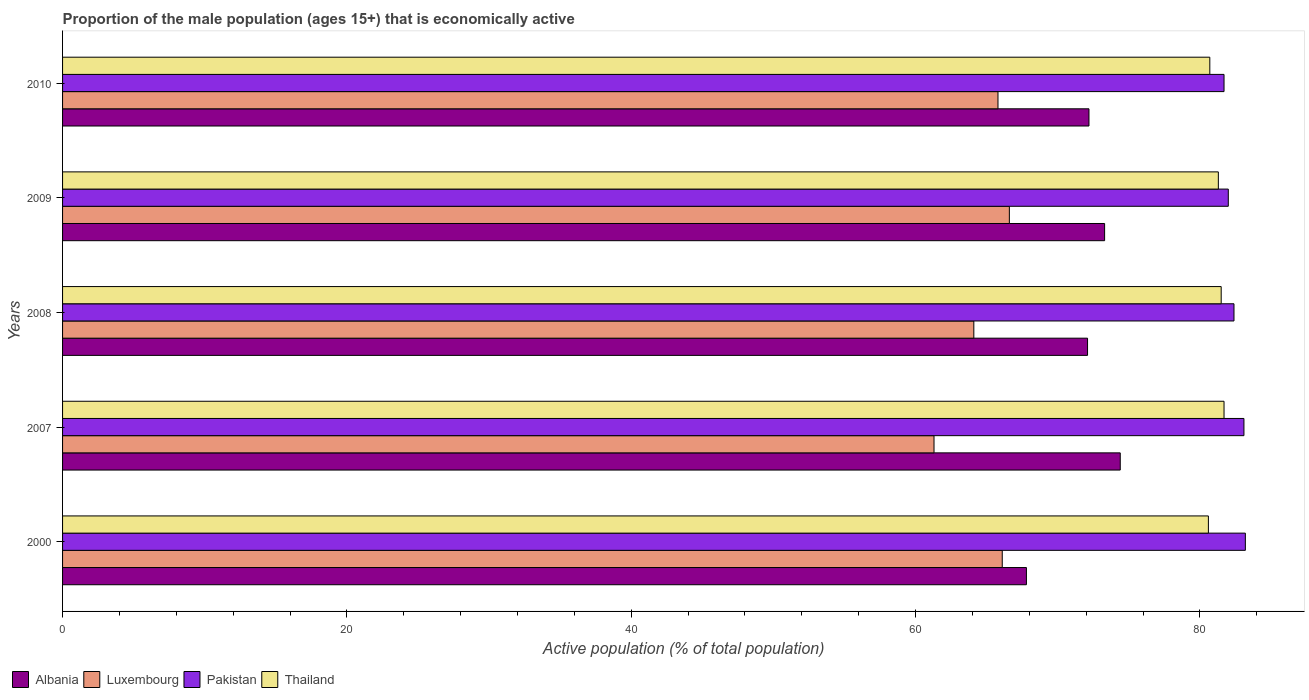Are the number of bars per tick equal to the number of legend labels?
Your answer should be very brief. Yes. Are the number of bars on each tick of the Y-axis equal?
Ensure brevity in your answer.  Yes. How many bars are there on the 2nd tick from the bottom?
Keep it short and to the point. 4. What is the proportion of the male population that is economically active in Thailand in 2009?
Your response must be concise. 81.3. Across all years, what is the maximum proportion of the male population that is economically active in Albania?
Offer a terse response. 74.4. Across all years, what is the minimum proportion of the male population that is economically active in Albania?
Give a very brief answer. 67.8. In which year was the proportion of the male population that is economically active in Thailand maximum?
Your answer should be very brief. 2007. What is the total proportion of the male population that is economically active in Albania in the graph?
Give a very brief answer. 359.8. What is the difference between the proportion of the male population that is economically active in Thailand in 2008 and that in 2009?
Your answer should be compact. 0.2. What is the difference between the proportion of the male population that is economically active in Pakistan in 2000 and the proportion of the male population that is economically active in Albania in 2008?
Provide a succinct answer. 11.1. What is the average proportion of the male population that is economically active in Albania per year?
Provide a short and direct response. 71.96. In the year 2010, what is the difference between the proportion of the male population that is economically active in Albania and proportion of the male population that is economically active in Luxembourg?
Provide a succinct answer. 6.4. What is the ratio of the proportion of the male population that is economically active in Thailand in 2000 to that in 2009?
Ensure brevity in your answer.  0.99. Is the proportion of the male population that is economically active in Thailand in 2000 less than that in 2009?
Give a very brief answer. Yes. Is the difference between the proportion of the male population that is economically active in Albania in 2000 and 2007 greater than the difference between the proportion of the male population that is economically active in Luxembourg in 2000 and 2007?
Keep it short and to the point. No. What is the difference between the highest and the lowest proportion of the male population that is economically active in Thailand?
Give a very brief answer. 1.1. Is the sum of the proportion of the male population that is economically active in Albania in 2007 and 2010 greater than the maximum proportion of the male population that is economically active in Pakistan across all years?
Provide a short and direct response. Yes. What does the 3rd bar from the top in 2010 represents?
Give a very brief answer. Luxembourg. How many bars are there?
Your answer should be very brief. 20. How many years are there in the graph?
Make the answer very short. 5. What is the difference between two consecutive major ticks on the X-axis?
Give a very brief answer. 20. Are the values on the major ticks of X-axis written in scientific E-notation?
Give a very brief answer. No. Does the graph contain grids?
Make the answer very short. No. Where does the legend appear in the graph?
Your answer should be compact. Bottom left. What is the title of the graph?
Provide a succinct answer. Proportion of the male population (ages 15+) that is economically active. Does "China" appear as one of the legend labels in the graph?
Ensure brevity in your answer.  No. What is the label or title of the X-axis?
Make the answer very short. Active population (% of total population). What is the label or title of the Y-axis?
Keep it short and to the point. Years. What is the Active population (% of total population) in Albania in 2000?
Ensure brevity in your answer.  67.8. What is the Active population (% of total population) of Luxembourg in 2000?
Your answer should be compact. 66.1. What is the Active population (% of total population) in Pakistan in 2000?
Your answer should be very brief. 83.2. What is the Active population (% of total population) of Thailand in 2000?
Ensure brevity in your answer.  80.6. What is the Active population (% of total population) of Albania in 2007?
Your answer should be very brief. 74.4. What is the Active population (% of total population) in Luxembourg in 2007?
Offer a terse response. 61.3. What is the Active population (% of total population) in Pakistan in 2007?
Ensure brevity in your answer.  83.1. What is the Active population (% of total population) of Thailand in 2007?
Provide a short and direct response. 81.7. What is the Active population (% of total population) of Albania in 2008?
Keep it short and to the point. 72.1. What is the Active population (% of total population) of Luxembourg in 2008?
Ensure brevity in your answer.  64.1. What is the Active population (% of total population) in Pakistan in 2008?
Offer a terse response. 82.4. What is the Active population (% of total population) of Thailand in 2008?
Make the answer very short. 81.5. What is the Active population (% of total population) in Albania in 2009?
Provide a short and direct response. 73.3. What is the Active population (% of total population) of Luxembourg in 2009?
Make the answer very short. 66.6. What is the Active population (% of total population) in Pakistan in 2009?
Your response must be concise. 82. What is the Active population (% of total population) in Thailand in 2009?
Provide a succinct answer. 81.3. What is the Active population (% of total population) in Albania in 2010?
Give a very brief answer. 72.2. What is the Active population (% of total population) of Luxembourg in 2010?
Give a very brief answer. 65.8. What is the Active population (% of total population) of Pakistan in 2010?
Offer a terse response. 81.7. What is the Active population (% of total population) of Thailand in 2010?
Your response must be concise. 80.7. Across all years, what is the maximum Active population (% of total population) of Albania?
Ensure brevity in your answer.  74.4. Across all years, what is the maximum Active population (% of total population) of Luxembourg?
Provide a short and direct response. 66.6. Across all years, what is the maximum Active population (% of total population) in Pakistan?
Make the answer very short. 83.2. Across all years, what is the maximum Active population (% of total population) in Thailand?
Keep it short and to the point. 81.7. Across all years, what is the minimum Active population (% of total population) in Albania?
Provide a succinct answer. 67.8. Across all years, what is the minimum Active population (% of total population) in Luxembourg?
Offer a terse response. 61.3. Across all years, what is the minimum Active population (% of total population) in Pakistan?
Provide a short and direct response. 81.7. Across all years, what is the minimum Active population (% of total population) in Thailand?
Your answer should be very brief. 80.6. What is the total Active population (% of total population) of Albania in the graph?
Provide a succinct answer. 359.8. What is the total Active population (% of total population) in Luxembourg in the graph?
Offer a very short reply. 323.9. What is the total Active population (% of total population) of Pakistan in the graph?
Your answer should be very brief. 412.4. What is the total Active population (% of total population) of Thailand in the graph?
Keep it short and to the point. 405.8. What is the difference between the Active population (% of total population) in Albania in 2000 and that in 2007?
Offer a very short reply. -6.6. What is the difference between the Active population (% of total population) of Pakistan in 2000 and that in 2007?
Provide a short and direct response. 0.1. What is the difference between the Active population (% of total population) of Thailand in 2000 and that in 2007?
Provide a short and direct response. -1.1. What is the difference between the Active population (% of total population) of Albania in 2000 and that in 2008?
Provide a succinct answer. -4.3. What is the difference between the Active population (% of total population) in Pakistan in 2000 and that in 2008?
Offer a very short reply. 0.8. What is the difference between the Active population (% of total population) in Pakistan in 2000 and that in 2009?
Your response must be concise. 1.2. What is the difference between the Active population (% of total population) in Thailand in 2000 and that in 2009?
Provide a short and direct response. -0.7. What is the difference between the Active population (% of total population) of Albania in 2000 and that in 2010?
Offer a terse response. -4.4. What is the difference between the Active population (% of total population) of Albania in 2007 and that in 2008?
Your answer should be compact. 2.3. What is the difference between the Active population (% of total population) of Luxembourg in 2007 and that in 2008?
Your answer should be very brief. -2.8. What is the difference between the Active population (% of total population) of Pakistan in 2007 and that in 2008?
Make the answer very short. 0.7. What is the difference between the Active population (% of total population) in Albania in 2007 and that in 2009?
Offer a terse response. 1.1. What is the difference between the Active population (% of total population) in Luxembourg in 2007 and that in 2009?
Keep it short and to the point. -5.3. What is the difference between the Active population (% of total population) of Pakistan in 2007 and that in 2009?
Give a very brief answer. 1.1. What is the difference between the Active population (% of total population) of Luxembourg in 2007 and that in 2010?
Offer a terse response. -4.5. What is the difference between the Active population (% of total population) in Pakistan in 2007 and that in 2010?
Make the answer very short. 1.4. What is the difference between the Active population (% of total population) of Thailand in 2007 and that in 2010?
Make the answer very short. 1. What is the difference between the Active population (% of total population) of Pakistan in 2008 and that in 2009?
Keep it short and to the point. 0.4. What is the difference between the Active population (% of total population) of Thailand in 2008 and that in 2009?
Keep it short and to the point. 0.2. What is the difference between the Active population (% of total population) of Albania in 2008 and that in 2010?
Your response must be concise. -0.1. What is the difference between the Active population (% of total population) of Pakistan in 2008 and that in 2010?
Offer a very short reply. 0.7. What is the difference between the Active population (% of total population) in Albania in 2009 and that in 2010?
Offer a very short reply. 1.1. What is the difference between the Active population (% of total population) of Albania in 2000 and the Active population (% of total population) of Luxembourg in 2007?
Provide a succinct answer. 6.5. What is the difference between the Active population (% of total population) in Albania in 2000 and the Active population (% of total population) in Pakistan in 2007?
Offer a very short reply. -15.3. What is the difference between the Active population (% of total population) of Luxembourg in 2000 and the Active population (% of total population) of Pakistan in 2007?
Your answer should be very brief. -17. What is the difference between the Active population (% of total population) in Luxembourg in 2000 and the Active population (% of total population) in Thailand in 2007?
Provide a short and direct response. -15.6. What is the difference between the Active population (% of total population) in Pakistan in 2000 and the Active population (% of total population) in Thailand in 2007?
Your answer should be very brief. 1.5. What is the difference between the Active population (% of total population) of Albania in 2000 and the Active population (% of total population) of Luxembourg in 2008?
Offer a very short reply. 3.7. What is the difference between the Active population (% of total population) in Albania in 2000 and the Active population (% of total population) in Pakistan in 2008?
Keep it short and to the point. -14.6. What is the difference between the Active population (% of total population) of Albania in 2000 and the Active population (% of total population) of Thailand in 2008?
Provide a short and direct response. -13.7. What is the difference between the Active population (% of total population) in Luxembourg in 2000 and the Active population (% of total population) in Pakistan in 2008?
Make the answer very short. -16.3. What is the difference between the Active population (% of total population) in Luxembourg in 2000 and the Active population (% of total population) in Thailand in 2008?
Keep it short and to the point. -15.4. What is the difference between the Active population (% of total population) of Albania in 2000 and the Active population (% of total population) of Luxembourg in 2009?
Provide a succinct answer. 1.2. What is the difference between the Active population (% of total population) in Albania in 2000 and the Active population (% of total population) in Pakistan in 2009?
Your answer should be compact. -14.2. What is the difference between the Active population (% of total population) in Albania in 2000 and the Active population (% of total population) in Thailand in 2009?
Ensure brevity in your answer.  -13.5. What is the difference between the Active population (% of total population) of Luxembourg in 2000 and the Active population (% of total population) of Pakistan in 2009?
Give a very brief answer. -15.9. What is the difference between the Active population (% of total population) in Luxembourg in 2000 and the Active population (% of total population) in Thailand in 2009?
Provide a short and direct response. -15.2. What is the difference between the Active population (% of total population) of Luxembourg in 2000 and the Active population (% of total population) of Pakistan in 2010?
Make the answer very short. -15.6. What is the difference between the Active population (% of total population) of Luxembourg in 2000 and the Active population (% of total population) of Thailand in 2010?
Your answer should be compact. -14.6. What is the difference between the Active population (% of total population) of Albania in 2007 and the Active population (% of total population) of Pakistan in 2008?
Make the answer very short. -8. What is the difference between the Active population (% of total population) in Albania in 2007 and the Active population (% of total population) in Thailand in 2008?
Make the answer very short. -7.1. What is the difference between the Active population (% of total population) in Luxembourg in 2007 and the Active population (% of total population) in Pakistan in 2008?
Keep it short and to the point. -21.1. What is the difference between the Active population (% of total population) in Luxembourg in 2007 and the Active population (% of total population) in Thailand in 2008?
Offer a terse response. -20.2. What is the difference between the Active population (% of total population) of Albania in 2007 and the Active population (% of total population) of Luxembourg in 2009?
Keep it short and to the point. 7.8. What is the difference between the Active population (% of total population) in Albania in 2007 and the Active population (% of total population) in Pakistan in 2009?
Ensure brevity in your answer.  -7.6. What is the difference between the Active population (% of total population) of Luxembourg in 2007 and the Active population (% of total population) of Pakistan in 2009?
Make the answer very short. -20.7. What is the difference between the Active population (% of total population) in Pakistan in 2007 and the Active population (% of total population) in Thailand in 2009?
Your answer should be compact. 1.8. What is the difference between the Active population (% of total population) in Albania in 2007 and the Active population (% of total population) in Luxembourg in 2010?
Give a very brief answer. 8.6. What is the difference between the Active population (% of total population) in Albania in 2007 and the Active population (% of total population) in Pakistan in 2010?
Offer a very short reply. -7.3. What is the difference between the Active population (% of total population) in Albania in 2007 and the Active population (% of total population) in Thailand in 2010?
Provide a succinct answer. -6.3. What is the difference between the Active population (% of total population) of Luxembourg in 2007 and the Active population (% of total population) of Pakistan in 2010?
Offer a very short reply. -20.4. What is the difference between the Active population (% of total population) in Luxembourg in 2007 and the Active population (% of total population) in Thailand in 2010?
Your answer should be very brief. -19.4. What is the difference between the Active population (% of total population) in Albania in 2008 and the Active population (% of total population) in Luxembourg in 2009?
Make the answer very short. 5.5. What is the difference between the Active population (% of total population) in Albania in 2008 and the Active population (% of total population) in Thailand in 2009?
Offer a very short reply. -9.2. What is the difference between the Active population (% of total population) in Luxembourg in 2008 and the Active population (% of total population) in Pakistan in 2009?
Your answer should be very brief. -17.9. What is the difference between the Active population (% of total population) in Luxembourg in 2008 and the Active population (% of total population) in Thailand in 2009?
Your answer should be very brief. -17.2. What is the difference between the Active population (% of total population) in Pakistan in 2008 and the Active population (% of total population) in Thailand in 2009?
Your response must be concise. 1.1. What is the difference between the Active population (% of total population) of Albania in 2008 and the Active population (% of total population) of Pakistan in 2010?
Keep it short and to the point. -9.6. What is the difference between the Active population (% of total population) in Luxembourg in 2008 and the Active population (% of total population) in Pakistan in 2010?
Provide a short and direct response. -17.6. What is the difference between the Active population (% of total population) of Luxembourg in 2008 and the Active population (% of total population) of Thailand in 2010?
Your response must be concise. -16.6. What is the difference between the Active population (% of total population) of Pakistan in 2008 and the Active population (% of total population) of Thailand in 2010?
Ensure brevity in your answer.  1.7. What is the difference between the Active population (% of total population) in Albania in 2009 and the Active population (% of total population) in Luxembourg in 2010?
Provide a succinct answer. 7.5. What is the difference between the Active population (% of total population) in Albania in 2009 and the Active population (% of total population) in Pakistan in 2010?
Make the answer very short. -8.4. What is the difference between the Active population (% of total population) in Albania in 2009 and the Active population (% of total population) in Thailand in 2010?
Keep it short and to the point. -7.4. What is the difference between the Active population (% of total population) in Luxembourg in 2009 and the Active population (% of total population) in Pakistan in 2010?
Give a very brief answer. -15.1. What is the difference between the Active population (% of total population) of Luxembourg in 2009 and the Active population (% of total population) of Thailand in 2010?
Your answer should be compact. -14.1. What is the average Active population (% of total population) of Albania per year?
Keep it short and to the point. 71.96. What is the average Active population (% of total population) in Luxembourg per year?
Make the answer very short. 64.78. What is the average Active population (% of total population) in Pakistan per year?
Offer a very short reply. 82.48. What is the average Active population (% of total population) in Thailand per year?
Provide a short and direct response. 81.16. In the year 2000, what is the difference between the Active population (% of total population) in Albania and Active population (% of total population) in Luxembourg?
Provide a short and direct response. 1.7. In the year 2000, what is the difference between the Active population (% of total population) in Albania and Active population (% of total population) in Pakistan?
Give a very brief answer. -15.4. In the year 2000, what is the difference between the Active population (% of total population) of Albania and Active population (% of total population) of Thailand?
Your response must be concise. -12.8. In the year 2000, what is the difference between the Active population (% of total population) of Luxembourg and Active population (% of total population) of Pakistan?
Your answer should be very brief. -17.1. In the year 2000, what is the difference between the Active population (% of total population) of Luxembourg and Active population (% of total population) of Thailand?
Your answer should be compact. -14.5. In the year 2007, what is the difference between the Active population (% of total population) of Albania and Active population (% of total population) of Pakistan?
Give a very brief answer. -8.7. In the year 2007, what is the difference between the Active population (% of total population) in Luxembourg and Active population (% of total population) in Pakistan?
Your response must be concise. -21.8. In the year 2007, what is the difference between the Active population (% of total population) of Luxembourg and Active population (% of total population) of Thailand?
Your answer should be compact. -20.4. In the year 2008, what is the difference between the Active population (% of total population) of Luxembourg and Active population (% of total population) of Pakistan?
Offer a very short reply. -18.3. In the year 2008, what is the difference between the Active population (% of total population) in Luxembourg and Active population (% of total population) in Thailand?
Provide a short and direct response. -17.4. In the year 2009, what is the difference between the Active population (% of total population) of Albania and Active population (% of total population) of Luxembourg?
Make the answer very short. 6.7. In the year 2009, what is the difference between the Active population (% of total population) of Luxembourg and Active population (% of total population) of Pakistan?
Give a very brief answer. -15.4. In the year 2009, what is the difference between the Active population (% of total population) of Luxembourg and Active population (% of total population) of Thailand?
Give a very brief answer. -14.7. In the year 2010, what is the difference between the Active population (% of total population) of Albania and Active population (% of total population) of Pakistan?
Make the answer very short. -9.5. In the year 2010, what is the difference between the Active population (% of total population) in Albania and Active population (% of total population) in Thailand?
Your answer should be very brief. -8.5. In the year 2010, what is the difference between the Active population (% of total population) of Luxembourg and Active population (% of total population) of Pakistan?
Make the answer very short. -15.9. In the year 2010, what is the difference between the Active population (% of total population) of Luxembourg and Active population (% of total population) of Thailand?
Provide a succinct answer. -14.9. What is the ratio of the Active population (% of total population) of Albania in 2000 to that in 2007?
Make the answer very short. 0.91. What is the ratio of the Active population (% of total population) in Luxembourg in 2000 to that in 2007?
Ensure brevity in your answer.  1.08. What is the ratio of the Active population (% of total population) of Thailand in 2000 to that in 2007?
Keep it short and to the point. 0.99. What is the ratio of the Active population (% of total population) in Albania in 2000 to that in 2008?
Ensure brevity in your answer.  0.94. What is the ratio of the Active population (% of total population) in Luxembourg in 2000 to that in 2008?
Give a very brief answer. 1.03. What is the ratio of the Active population (% of total population) of Pakistan in 2000 to that in 2008?
Offer a terse response. 1.01. What is the ratio of the Active population (% of total population) in Thailand in 2000 to that in 2008?
Offer a terse response. 0.99. What is the ratio of the Active population (% of total population) of Albania in 2000 to that in 2009?
Provide a succinct answer. 0.93. What is the ratio of the Active population (% of total population) of Luxembourg in 2000 to that in 2009?
Provide a short and direct response. 0.99. What is the ratio of the Active population (% of total population) in Pakistan in 2000 to that in 2009?
Keep it short and to the point. 1.01. What is the ratio of the Active population (% of total population) of Thailand in 2000 to that in 2009?
Offer a terse response. 0.99. What is the ratio of the Active population (% of total population) of Albania in 2000 to that in 2010?
Provide a short and direct response. 0.94. What is the ratio of the Active population (% of total population) of Luxembourg in 2000 to that in 2010?
Provide a short and direct response. 1. What is the ratio of the Active population (% of total population) of Pakistan in 2000 to that in 2010?
Provide a short and direct response. 1.02. What is the ratio of the Active population (% of total population) of Thailand in 2000 to that in 2010?
Provide a short and direct response. 1. What is the ratio of the Active population (% of total population) of Albania in 2007 to that in 2008?
Offer a terse response. 1.03. What is the ratio of the Active population (% of total population) of Luxembourg in 2007 to that in 2008?
Provide a succinct answer. 0.96. What is the ratio of the Active population (% of total population) of Pakistan in 2007 to that in 2008?
Keep it short and to the point. 1.01. What is the ratio of the Active population (% of total population) of Albania in 2007 to that in 2009?
Make the answer very short. 1.01. What is the ratio of the Active population (% of total population) of Luxembourg in 2007 to that in 2009?
Ensure brevity in your answer.  0.92. What is the ratio of the Active population (% of total population) of Pakistan in 2007 to that in 2009?
Give a very brief answer. 1.01. What is the ratio of the Active population (% of total population) in Albania in 2007 to that in 2010?
Keep it short and to the point. 1.03. What is the ratio of the Active population (% of total population) in Luxembourg in 2007 to that in 2010?
Your answer should be very brief. 0.93. What is the ratio of the Active population (% of total population) of Pakistan in 2007 to that in 2010?
Make the answer very short. 1.02. What is the ratio of the Active population (% of total population) in Thailand in 2007 to that in 2010?
Your answer should be very brief. 1.01. What is the ratio of the Active population (% of total population) in Albania in 2008 to that in 2009?
Offer a terse response. 0.98. What is the ratio of the Active population (% of total population) in Luxembourg in 2008 to that in 2009?
Provide a short and direct response. 0.96. What is the ratio of the Active population (% of total population) in Albania in 2008 to that in 2010?
Your response must be concise. 1. What is the ratio of the Active population (% of total population) in Luxembourg in 2008 to that in 2010?
Offer a terse response. 0.97. What is the ratio of the Active population (% of total population) of Pakistan in 2008 to that in 2010?
Offer a terse response. 1.01. What is the ratio of the Active population (% of total population) in Thailand in 2008 to that in 2010?
Your response must be concise. 1.01. What is the ratio of the Active population (% of total population) of Albania in 2009 to that in 2010?
Give a very brief answer. 1.02. What is the ratio of the Active population (% of total population) in Luxembourg in 2009 to that in 2010?
Provide a short and direct response. 1.01. What is the ratio of the Active population (% of total population) of Thailand in 2009 to that in 2010?
Provide a succinct answer. 1.01. What is the difference between the highest and the second highest Active population (% of total population) in Luxembourg?
Ensure brevity in your answer.  0.5. What is the difference between the highest and the second highest Active population (% of total population) in Pakistan?
Provide a short and direct response. 0.1. What is the difference between the highest and the second highest Active population (% of total population) of Thailand?
Offer a terse response. 0.2. What is the difference between the highest and the lowest Active population (% of total population) of Albania?
Keep it short and to the point. 6.6. What is the difference between the highest and the lowest Active population (% of total population) in Luxembourg?
Ensure brevity in your answer.  5.3. What is the difference between the highest and the lowest Active population (% of total population) of Pakistan?
Give a very brief answer. 1.5. 